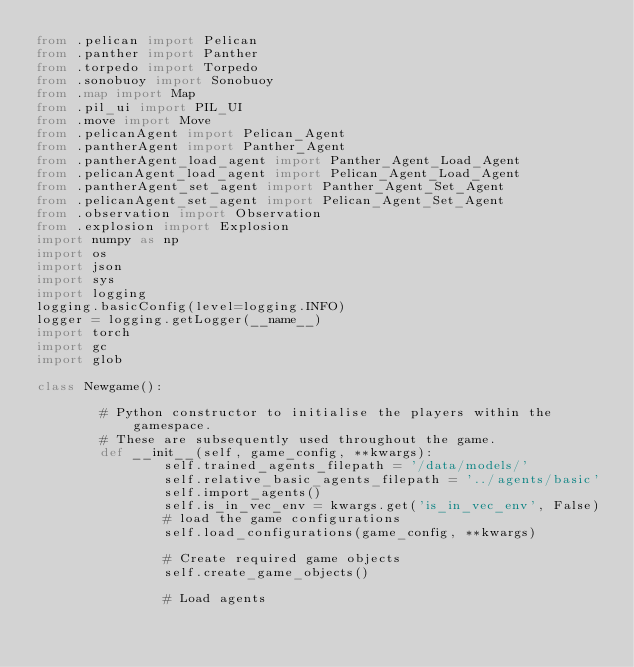<code> <loc_0><loc_0><loc_500><loc_500><_Python_>from .pelican import Pelican
from .panther import Panther
from .torpedo import Torpedo
from .sonobuoy import Sonobuoy
from .map import Map
from .pil_ui import PIL_UI
from .move import Move
from .pelicanAgent import Pelican_Agent
from .pantherAgent import Panther_Agent
from .pantherAgent_load_agent import Panther_Agent_Load_Agent
from .pelicanAgent_load_agent import Pelican_Agent_Load_Agent
from .pantherAgent_set_agent import Panther_Agent_Set_Agent
from .pelicanAgent_set_agent import Pelican_Agent_Set_Agent
from .observation import Observation
from .explosion import Explosion
import numpy as np
import os
import json
import sys
import logging
logging.basicConfig(level=logging.INFO)
logger = logging.getLogger(__name__)
import torch
import gc
import glob

class Newgame():

        # Python constructor to initialise the players within the gamespace.
        # These are subsequently used throughout the game.
        def __init__(self, game_config, **kwargs):
                self.trained_agents_filepath = '/data/models/'
                self.relative_basic_agents_filepath = '../agents/basic'
                self.import_agents()
                self.is_in_vec_env = kwargs.get('is_in_vec_env', False) 
                # load the game configurations
                self.load_configurations(game_config, **kwargs)

                # Create required game objects
                self.create_game_objects()

                # Load agents</code> 